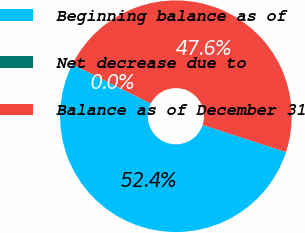Convert chart. <chart><loc_0><loc_0><loc_500><loc_500><pie_chart><fcel>Beginning balance as of<fcel>Net decrease due to<fcel>Balance as of December 31<nl><fcel>52.36%<fcel>0.03%<fcel>47.6%<nl></chart> 